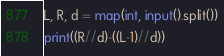Convert code to text. <code><loc_0><loc_0><loc_500><loc_500><_Python_>L, R, d = map(int, input().split())
print((R//d)-((L-1)//d))</code> 